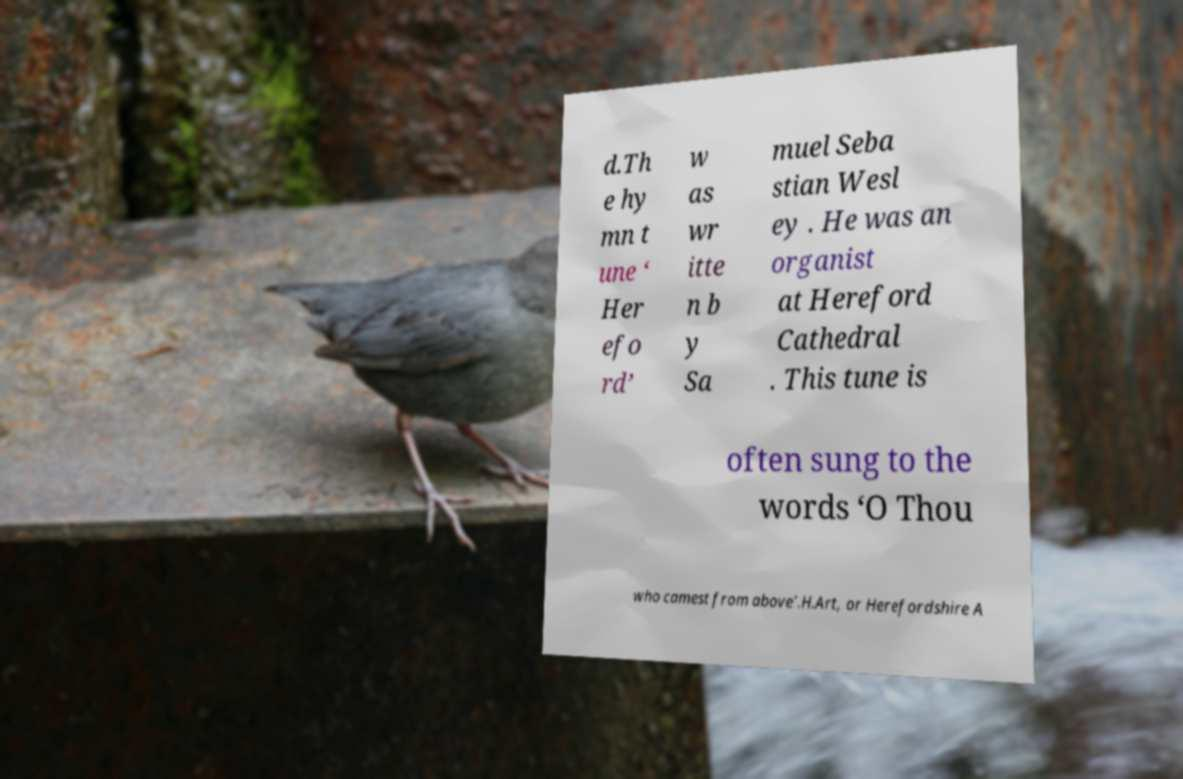Please read and relay the text visible in this image. What does it say? d.Th e hy mn t une ‘ Her efo rd’ w as wr itte n b y Sa muel Seba stian Wesl ey . He was an organist at Hereford Cathedral . This tune is often sung to the words ‘O Thou who camest from above’.H.Art, or Herefordshire A 